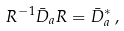<formula> <loc_0><loc_0><loc_500><loc_500>R ^ { - 1 } \bar { D } _ { a } R = \bar { D } _ { a } ^ { * } \, ,</formula> 